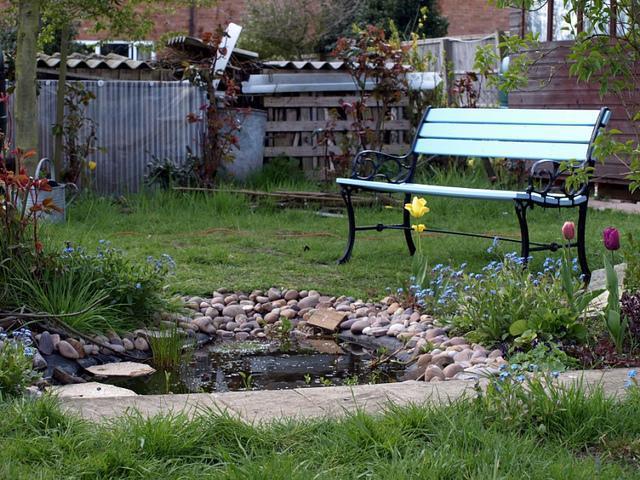How many benches are there?
Give a very brief answer. 1. How many red cars are there?
Give a very brief answer. 0. 